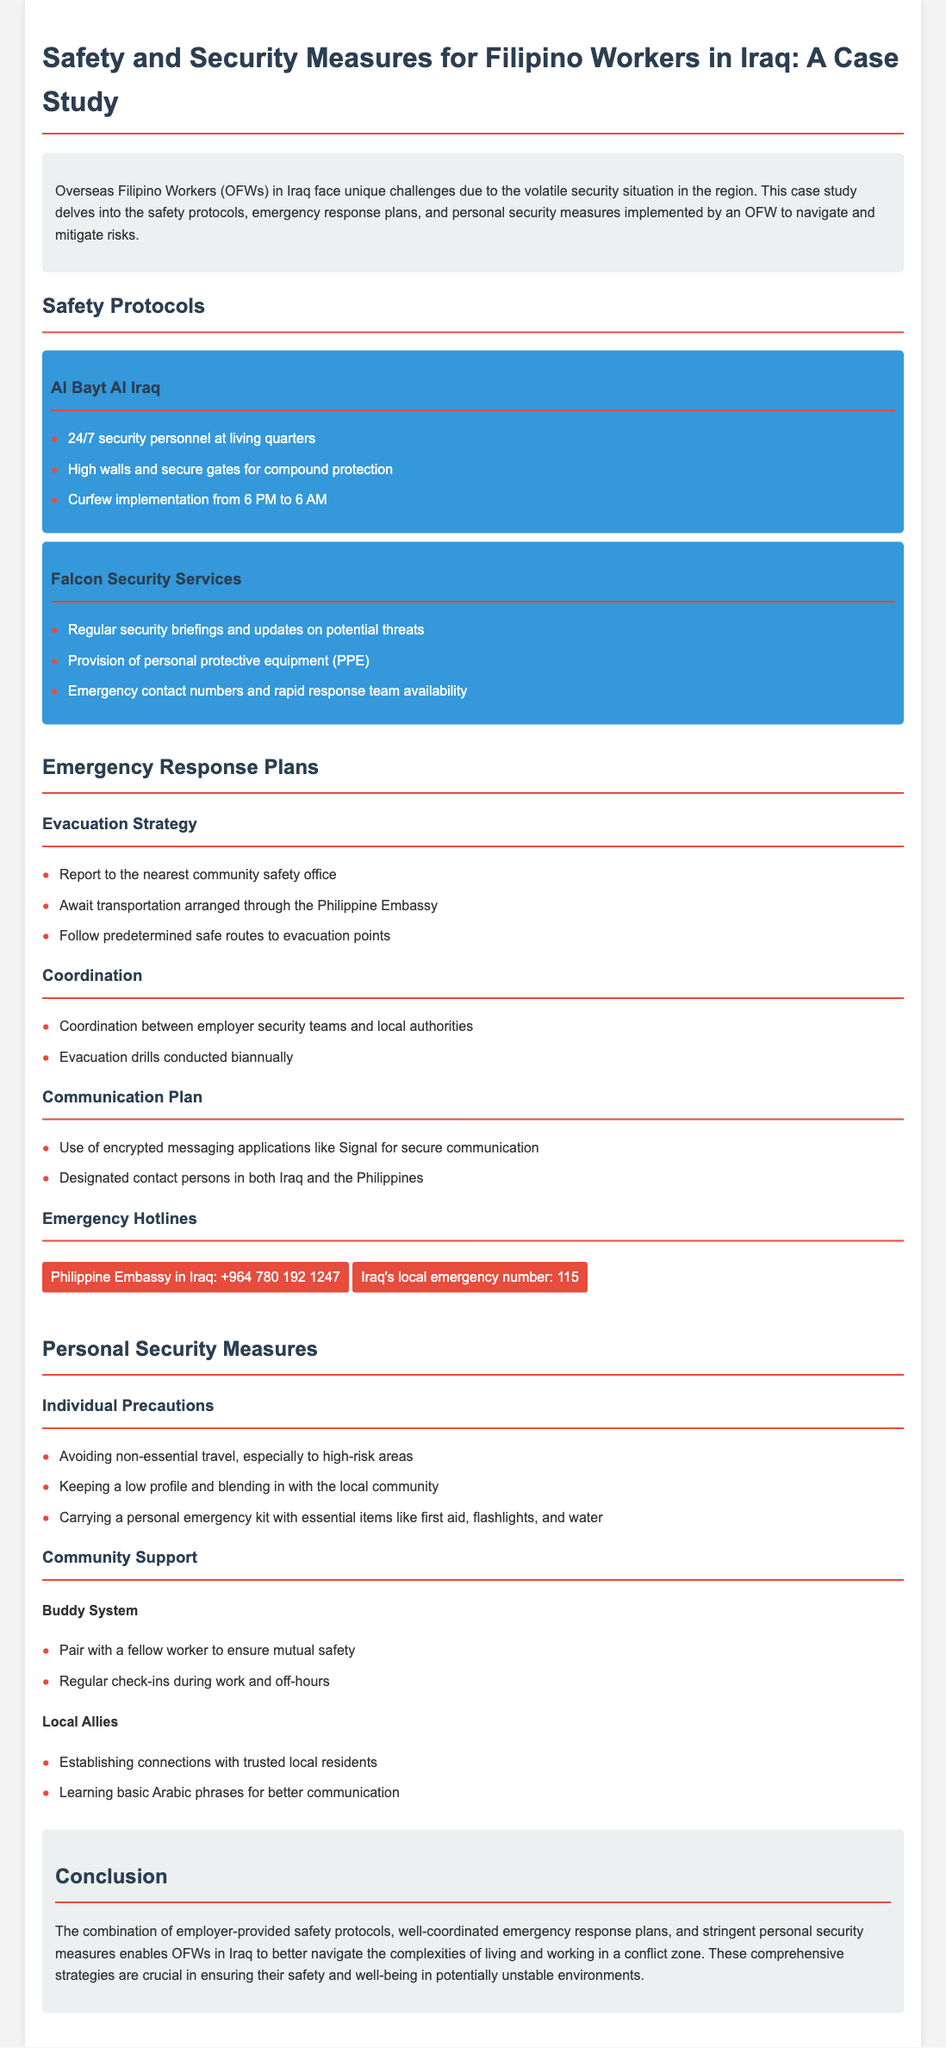What security feature is mentioned for the living quarters? The document states that there is 24/7 security personnel at living quarters, which is a specific safety feature implemented.
Answer: 24/7 security personnel What company provides personal protective equipment? The document identifies Falcon Security Services as the provider of personal protective equipment, indicating their role in ensuring worker safety.
Answer: Falcon Security Services What is the curfew time implemented in the compound? The document clearly states a curfew implementation from 6 PM to 6 AM, defining the restricted hours for workers.
Answer: 6 PM to 6 AM How often are evacuation drills conducted? According to the document, evacuation drills are conducted biannually, providing insight into the emergency preparedness procedures.
Answer: Biannually What is one personal precaution mentioned? The document enumerates a list of individual precautions, and avoiding non-essential travel is explicitly cited as one of them.
Answer: Avoiding non-essential travel How is secure communication ensured during emergencies? The use of encrypted messaging applications like Signal is provided in the document as a method for secure communication during emergencies.
Answer: Encrypted messaging applications What is one way to establish local support? The document mentions establishing connections with trusted local residents as a way to gain community support for safety.
Answer: Trusted local residents What is the emergency hotline for the Philippine Embassy in Iraq? The document includes specific emergency contact numbers, with the Philippine Embassy hotline being provided for immediate assistance.
Answer: +964 780 192 1247 